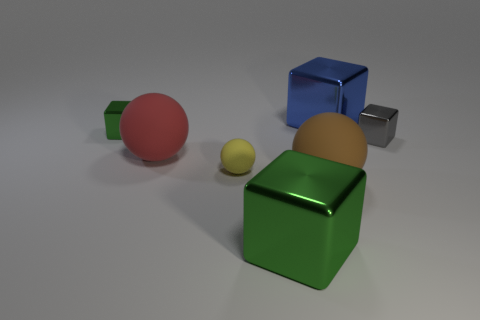Subtract all big rubber balls. How many balls are left? 1 Add 1 large red spheres. How many objects exist? 8 Subtract all blue cubes. How many cubes are left? 3 Subtract all balls. How many objects are left? 4 Subtract 0 yellow cubes. How many objects are left? 7 Subtract 1 balls. How many balls are left? 2 Subtract all brown balls. Subtract all green cylinders. How many balls are left? 2 Subtract all green balls. How many yellow cubes are left? 0 Subtract all small green shiny cubes. Subtract all rubber things. How many objects are left? 3 Add 4 large brown rubber spheres. How many large brown rubber spheres are left? 5 